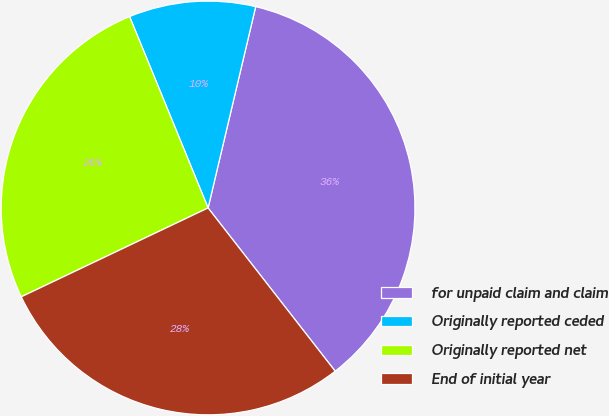<chart> <loc_0><loc_0><loc_500><loc_500><pie_chart><fcel>for unpaid claim and claim<fcel>Originally reported ceded<fcel>Originally reported net<fcel>End of initial year<nl><fcel>35.77%<fcel>9.89%<fcel>25.87%<fcel>28.46%<nl></chart> 